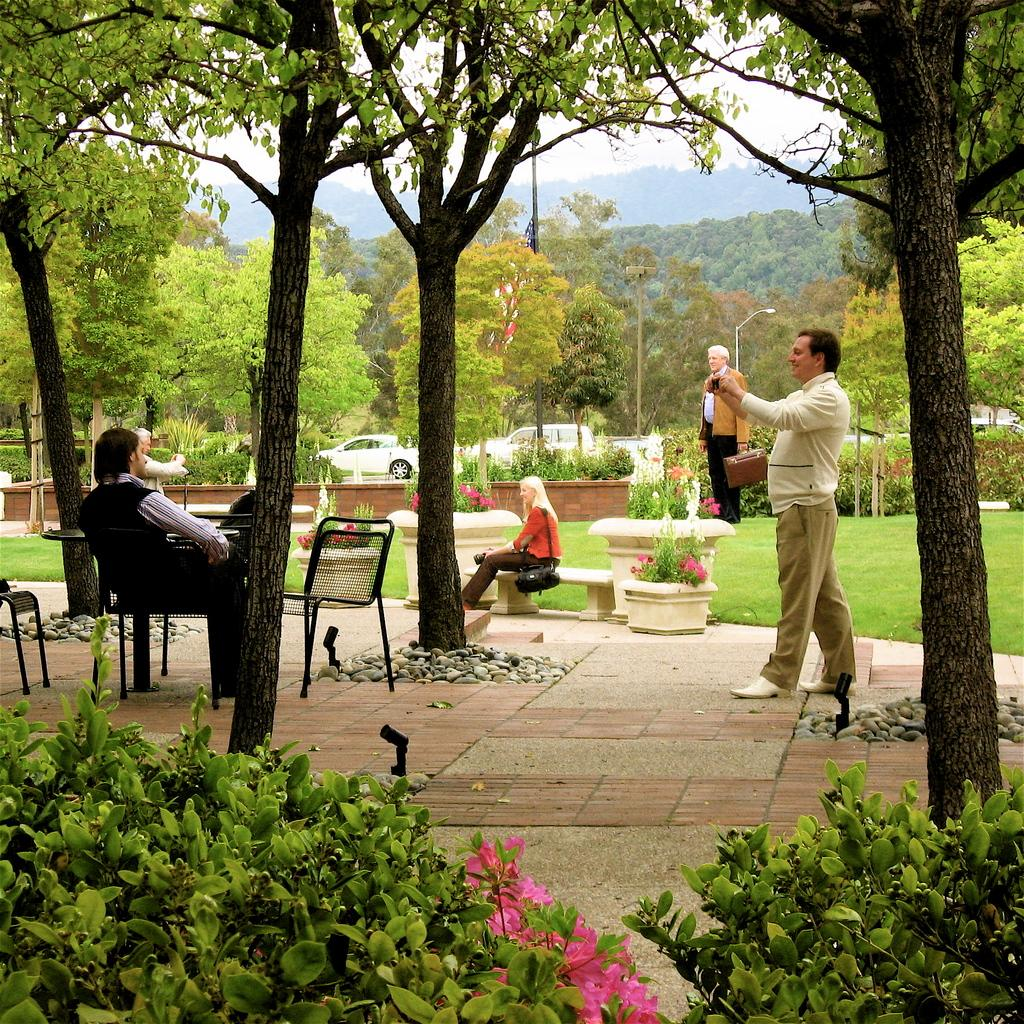How many people are present in the image? There are three persons sitting and two persons standing, making a total of five people in the image. What are the people doing in the image? The three persons are sitting, and the other two are standing. What type of vegetation can be seen in the image? There are small bushes with flowers and trees in the image. What can be seen in the background of the image? Cars are parked in the background of the image. Are there any chairs in the image? Yes, there are empty chairs in the image. What type of teeth can be seen in the image? There are no teeth visible in the image; it features people and objects in an outdoor setting. 